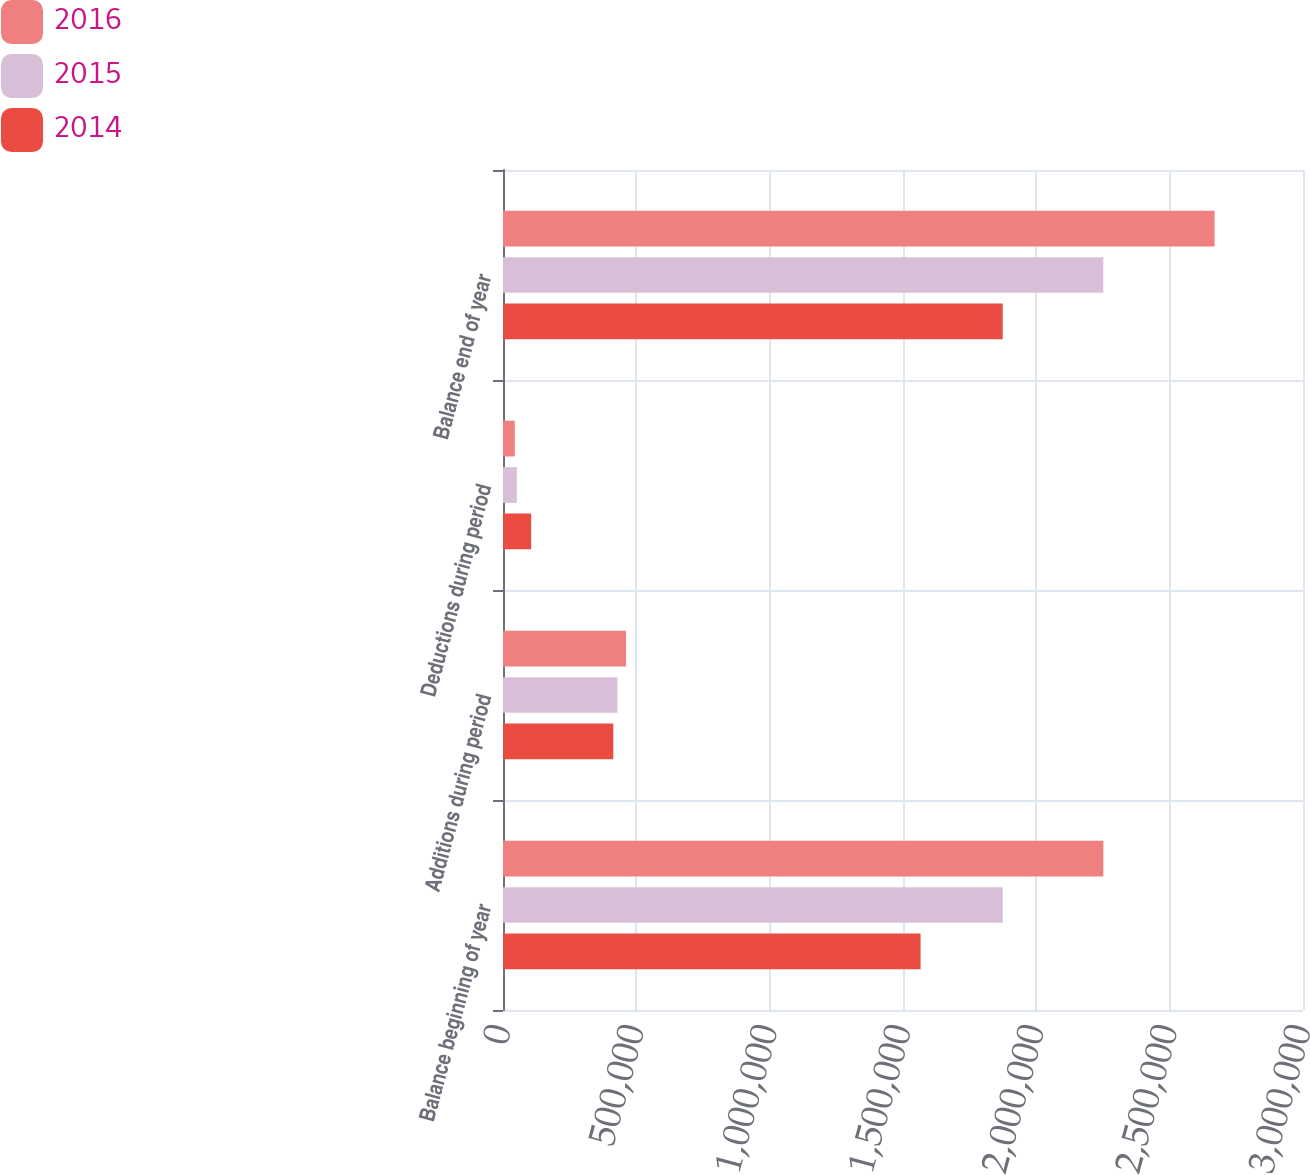Convert chart. <chart><loc_0><loc_0><loc_500><loc_500><stacked_bar_chart><ecel><fcel>Balance beginning of year<fcel>Additions during period<fcel>Deductions during period<fcel>Balance end of year<nl><fcel>2016<fcel>2.25127e+06<fcel>461506<fcel>44265<fcel>2.66851e+06<nl><fcel>2015<fcel>1.87405e+06<fcel>429057<fcel>51843<fcel>2.25127e+06<nl><fcel>2014<fcel>1.566e+06<fcel>413652<fcel>105594<fcel>1.87405e+06<nl></chart> 